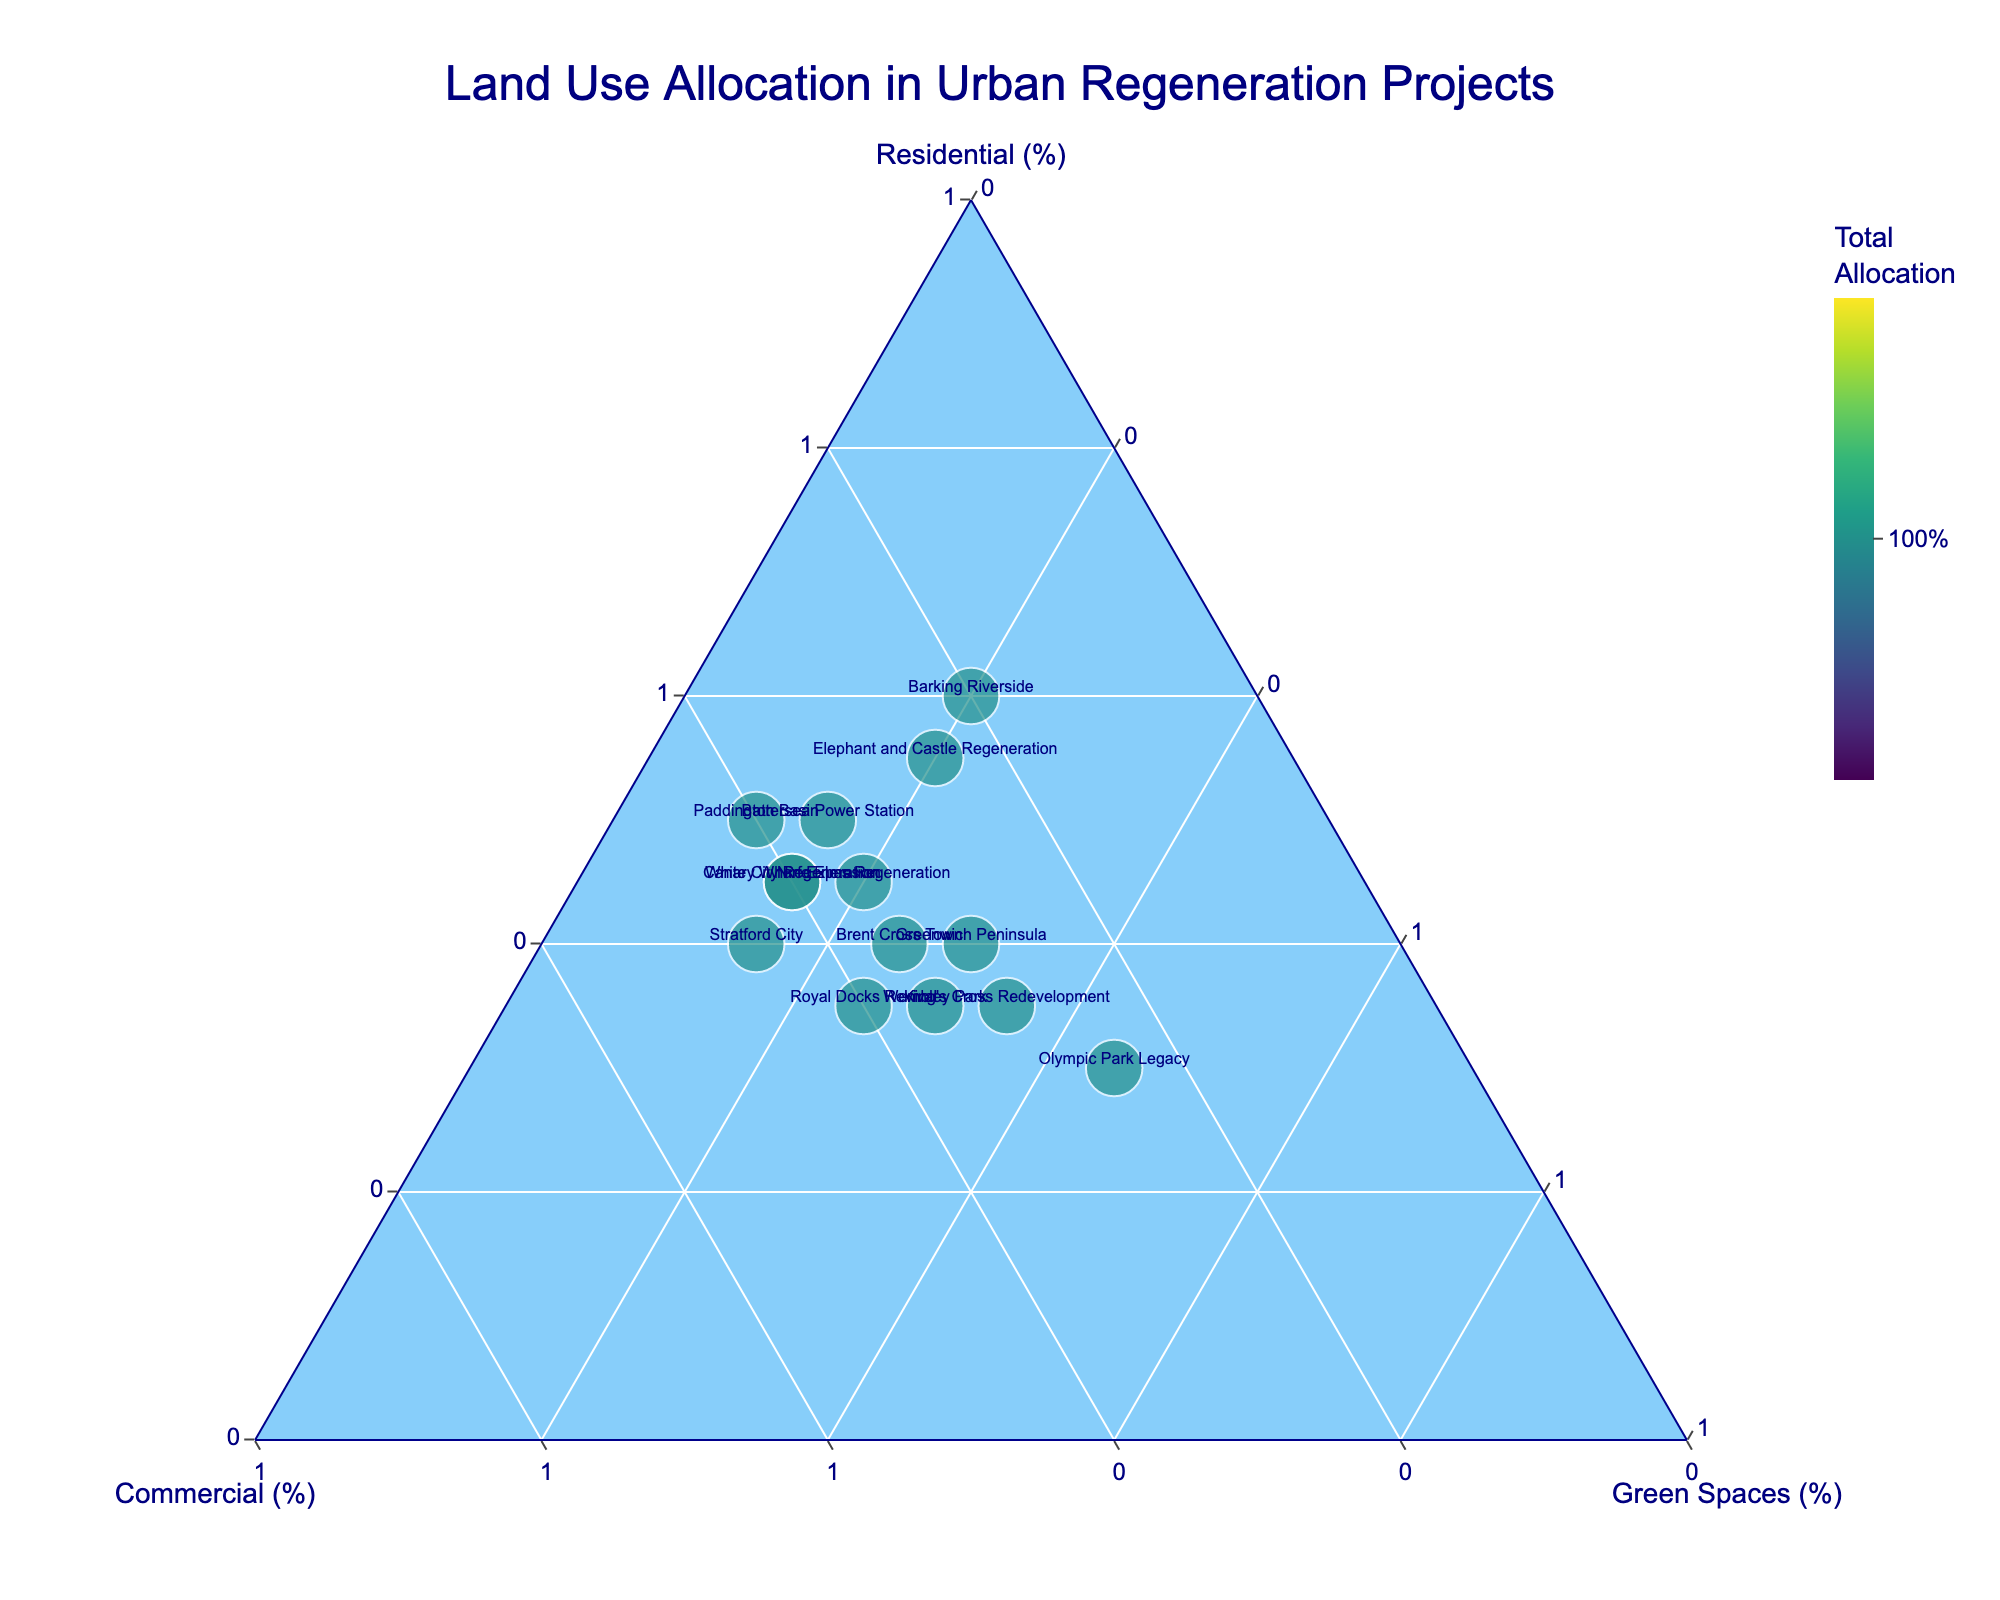What is the title of the ternary plot? The title of a plot is typically found at the top of the figure. In this case, it would be directly displayed there.
Answer: Land Use Allocation in Urban Regeneration Projects Which project has the highest percentage of green spaces? To find this, locate the data point closest to the "Green Spaces (%)" apex.
Answer: Olympic Park Legacy How are the percentages of residential and commercial use related for the Canary Wharf Expansion project? For the Canary Wharf Expansion project, refer to its position on the ternary plot to compare the Residential (%) and Commercial (%).
Answer: 45% Residential, 40% Commercial What is the total allocation for Paddington Basin and which area uses the most percentage-wise? The color and size of the marker represent the total allocation. The values are annotated in the data points. The largest percentage area can be identified from the ternary plot.
Answer: 100, Residential (50%) Which projects have the same percentage of green spaces? Identify data points with similar positions along the Green Spaces (%) axis to find projects with equal green space allocation.
Answer: Canary Wharf Expansion, Battersea Power Station, Stratford City, White City Regeneration (15%) Which project balances residential, commercial, and green spaces the best? Determine which data point is closest to the center of the ternary plot (where all three values are equal).
Answer: King's Cross Redevelopment Compare the total allocation between Nine Elms Regeneration and Greenwich Peninsula. Which project has a higher total allocation? Compare the color and size of the markers for both data points. The one with a darker shade and larger size has a higher total allocation.
Answer: Nine Elms Regeneration What is the average percentage of commercial spaces across all projects? Sum up all commercial percentages and divide by the number of projects.
Answer: 33.57% Which project has more residential allocation: Elephant and Castle Regeneration or Barking Riverside? Compare these two data points, checking the distance from the Residential axis: Elephant and Castle Regeneration 55%, Barking Riverside 60%.
Answer: Barking Riverside Which project is represented by the largest marker on the plot? Identify the largest marker by its size and check the hover text or labels upon viewing.
Answer: Barking Riverside 